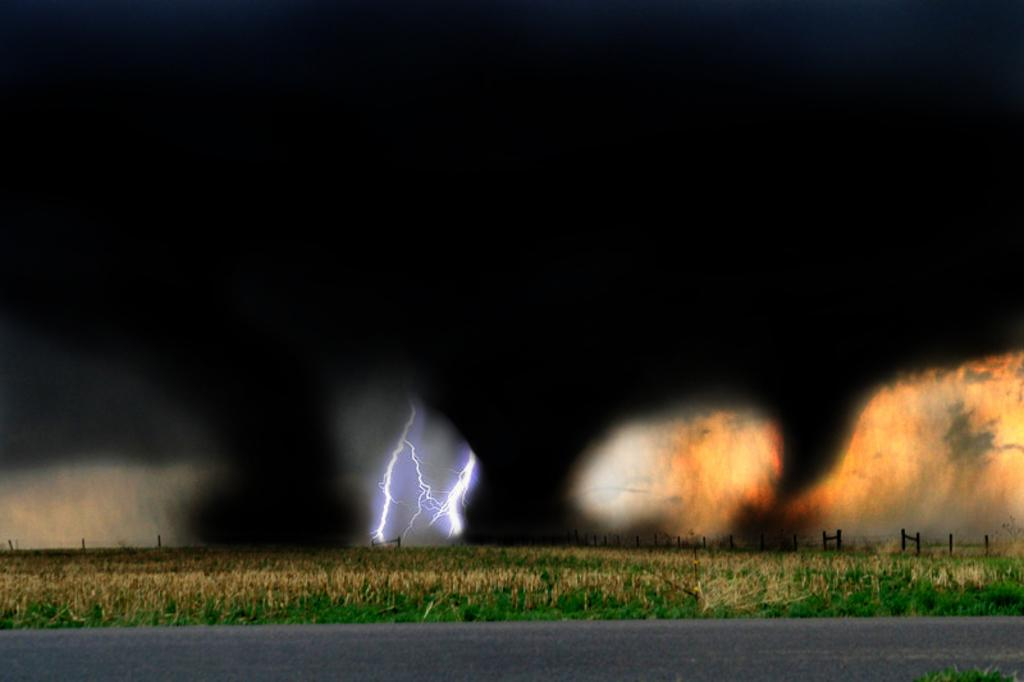What type of surface can be seen in the image? There is a road visible in the image. What type of vegetation is visible in the image? There is grass visible in the image. What type of element is visible in the image? There is fire visible in the image. What type of visual effect is visible in the image? There are sparkles visible in the image. What is the color of the background in the image? The background of the image is dark. What type of apparel is visible in the image? There is no apparel visible in the image. What type of spark can be seen in the image? There is no specific type of spark visible in the image; there are just sparkles. What type of tub is visible in the image? There is no tub present in the image. 